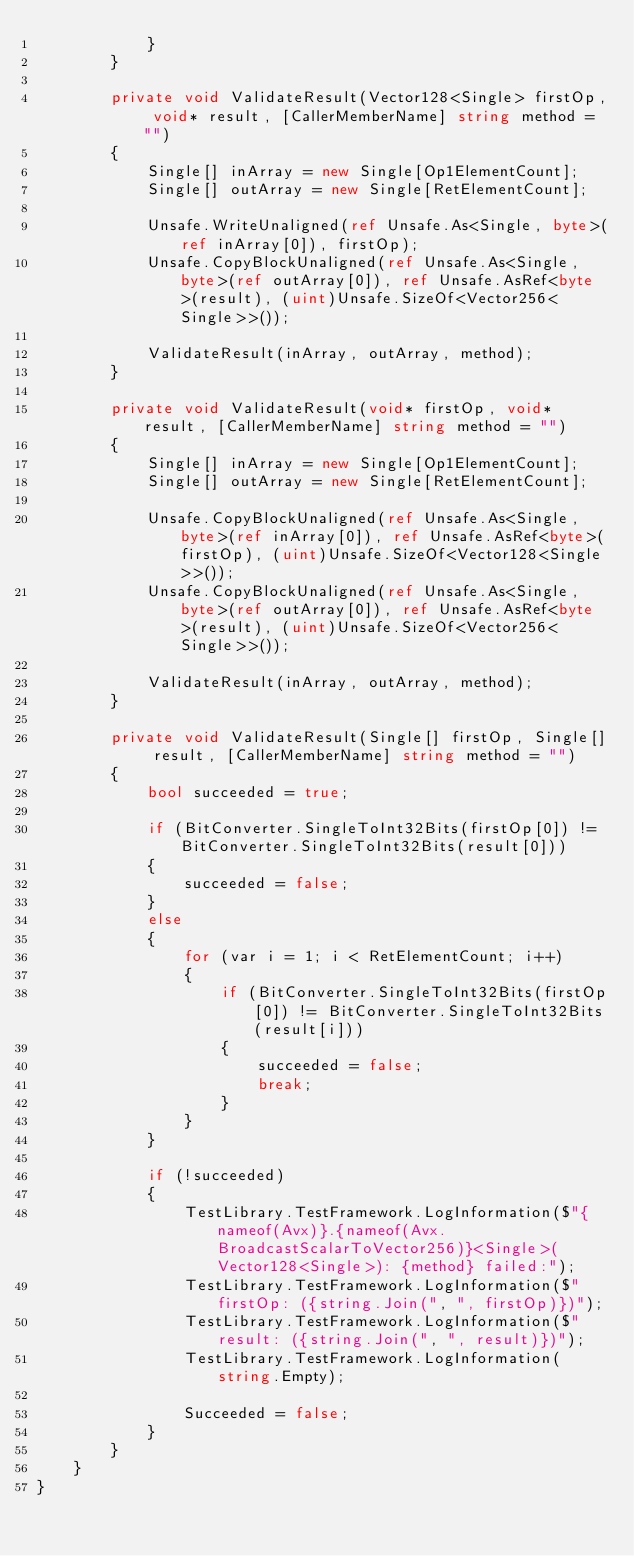Convert code to text. <code><loc_0><loc_0><loc_500><loc_500><_C#_>            }
        }

        private void ValidateResult(Vector128<Single> firstOp, void* result, [CallerMemberName] string method = "")
        {
            Single[] inArray = new Single[Op1ElementCount];
            Single[] outArray = new Single[RetElementCount];

            Unsafe.WriteUnaligned(ref Unsafe.As<Single, byte>(ref inArray[0]), firstOp);
            Unsafe.CopyBlockUnaligned(ref Unsafe.As<Single, byte>(ref outArray[0]), ref Unsafe.AsRef<byte>(result), (uint)Unsafe.SizeOf<Vector256<Single>>());

            ValidateResult(inArray, outArray, method);
        }

        private void ValidateResult(void* firstOp, void* result, [CallerMemberName] string method = "")
        {
            Single[] inArray = new Single[Op1ElementCount];
            Single[] outArray = new Single[RetElementCount];

            Unsafe.CopyBlockUnaligned(ref Unsafe.As<Single, byte>(ref inArray[0]), ref Unsafe.AsRef<byte>(firstOp), (uint)Unsafe.SizeOf<Vector128<Single>>());
            Unsafe.CopyBlockUnaligned(ref Unsafe.As<Single, byte>(ref outArray[0]), ref Unsafe.AsRef<byte>(result), (uint)Unsafe.SizeOf<Vector256<Single>>());

            ValidateResult(inArray, outArray, method);
        }

        private void ValidateResult(Single[] firstOp, Single[] result, [CallerMemberName] string method = "")
        {
            bool succeeded = true;

            if (BitConverter.SingleToInt32Bits(firstOp[0]) != BitConverter.SingleToInt32Bits(result[0]))
            {
                succeeded = false;
            }
            else
            {
                for (var i = 1; i < RetElementCount; i++)
                {
                    if (BitConverter.SingleToInt32Bits(firstOp[0]) != BitConverter.SingleToInt32Bits(result[i]))
                    {
                        succeeded = false;
                        break;
                    }
                }
            }

            if (!succeeded)
            {
                TestLibrary.TestFramework.LogInformation($"{nameof(Avx)}.{nameof(Avx.BroadcastScalarToVector256)}<Single>(Vector128<Single>): {method} failed:");
                TestLibrary.TestFramework.LogInformation($"  firstOp: ({string.Join(", ", firstOp)})");
                TestLibrary.TestFramework.LogInformation($"   result: ({string.Join(", ", result)})");
                TestLibrary.TestFramework.LogInformation(string.Empty);

                Succeeded = false;
            }
        }
    }
}
</code> 